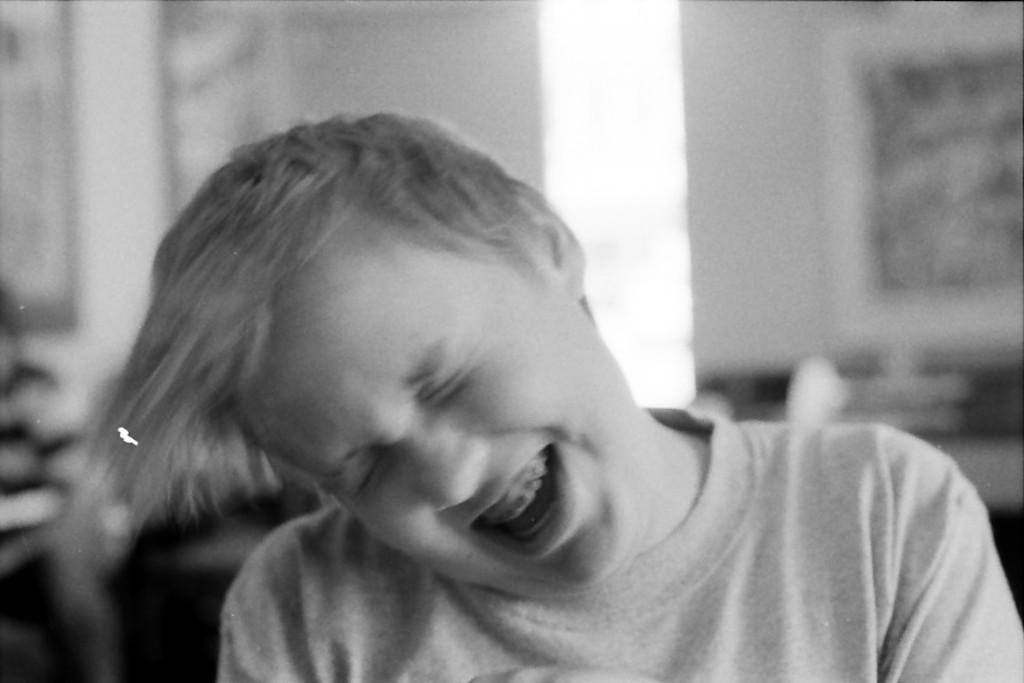How would you summarize this image in a sentence or two? It looks like a black and white picture. We can see a person and behind the person there is the blurred background. 